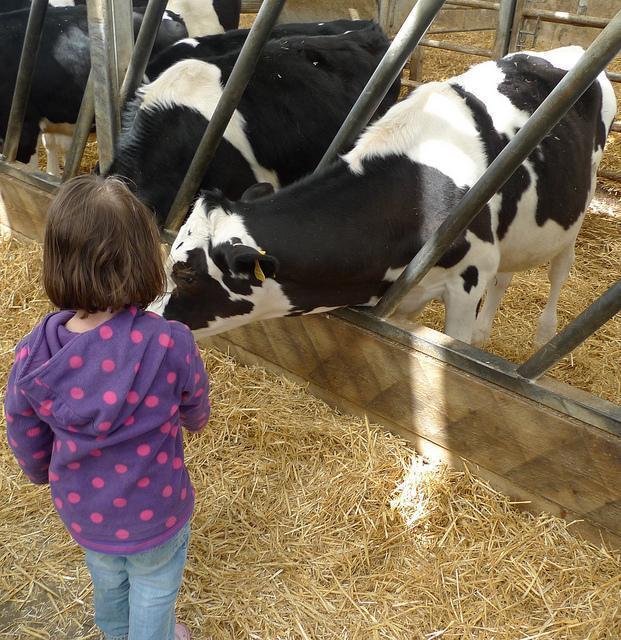How many spots on the cow?
Give a very brief answer. 6. How many cows are in the picture?
Give a very brief answer. 4. 